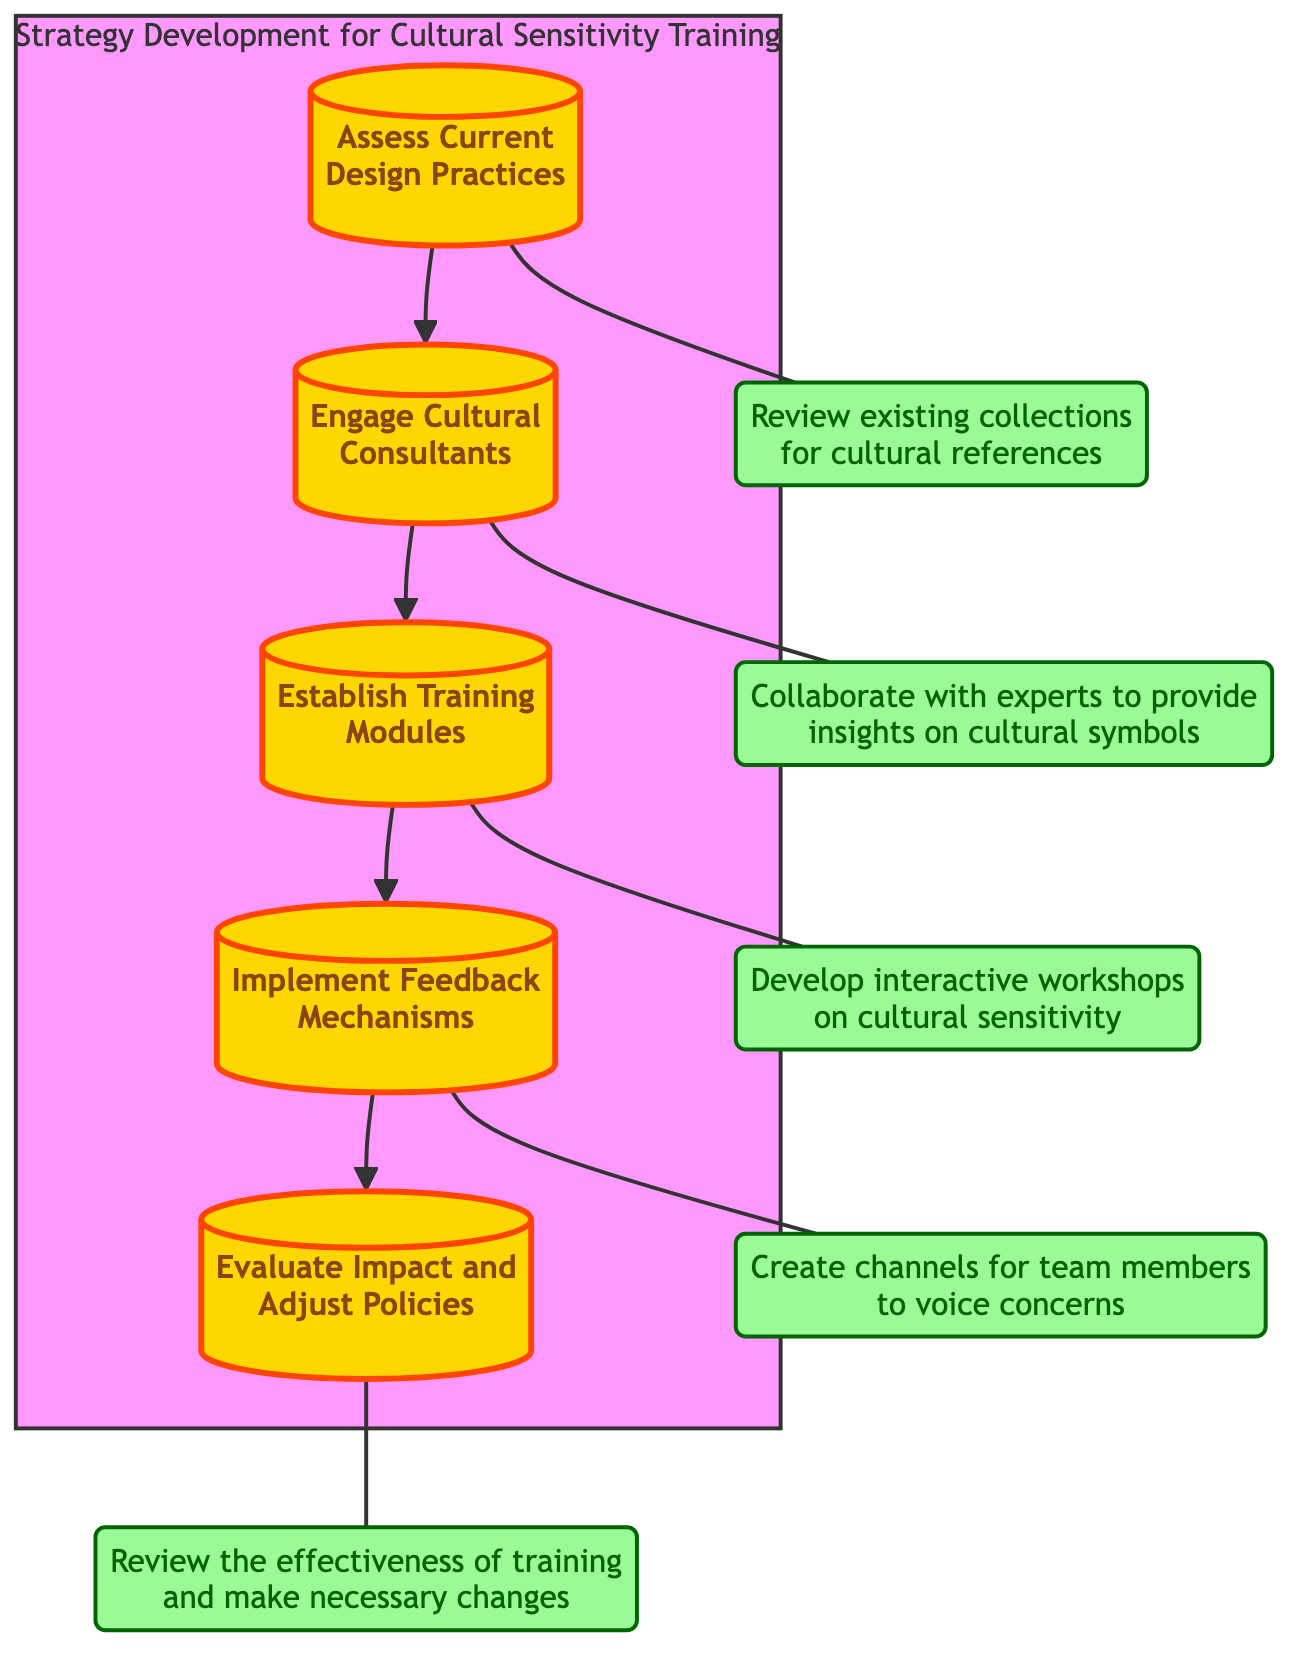What is the first step in the flow chart? According to the diagram, the first step is listed as "Assess Current Design Practices" which is the starting point of the flow.
Answer: Assess Current Design Practices How many steps are included in the strategy development process? The diagram contains a total of five steps connecting from the initial action to the evaluation of the process.
Answer: Five What does the second step focus on? The second step in the flow chart is "Engage Cultural Consultants," which emphasizes collaboration with experts on cultural symbols.
Answer: Engage Cultural Consultants What action follows "Establish Training Modules"? In the flow of the diagram, "Implement Feedback Mechanisms" is the next action that occurs after establishing training modules.
Answer: Implement Feedback Mechanisms What is the primary goal of the fifth step? The fifth step, "Evaluate Impact and Adjust Policies," aims to review how effective the training has been and to make necessary changes based on the feedback collected.
Answer: Review the effectiveness of training Which step involves creating channels for feedback? "Implement Feedback Mechanisms" is the step that includes the creation of channels for team members to voice their concerns about the design practices.
Answer: Implement Feedback Mechanisms How many descriptions are associated with the steps? Each of the five steps has an associated description, leading to a total of five descriptions provided in the diagram.
Answer: Five What relationship exists between "Engage Cultural Consultants" and "Establish Training Modules"? The relationship shows a sequential flow where "Engage Cultural Consultants" leads to "Establish Training Modules," indicating that consultant input informs the training creation.
Answer: Sequential flow What is the focus of the training modules established in the third step? The focus of the training modules is to develop interactive workshops on cultural sensitivity, as outlined in the description of the third step.
Answer: Cultural sensitivity What action is taken before evaluating the impact of the training? The step taken before evaluating the impact is "Implement Feedback Mechanisms," where feedback channels are created, allowing for insights that inform the evaluation.
Answer: Implement Feedback Mechanisms 